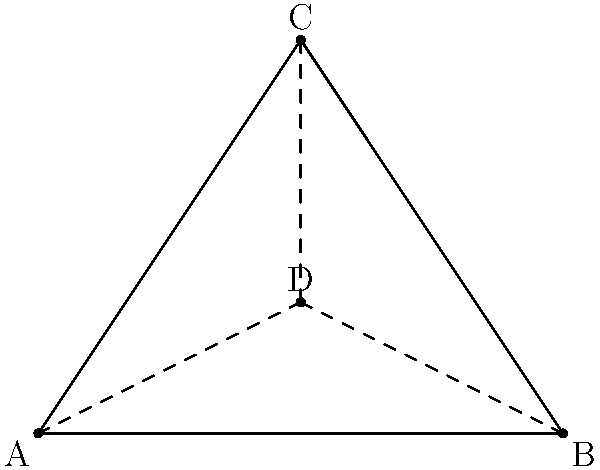In the 1979 South Melbourne FC season, coach Ian Dobson was known for his innovative tactical formations. If he arranged three key players (A, B, and C) in a triangular formation on the field, where should he position the team captain (D) to ensure equal distance from all three players, maximizing communication efficiency? To find the optimal position for the team captain (D) that ensures equal distance from all three players (A, B, and C), we need to follow these steps:

1. Recognize that the point we're looking for is the center of the triangle ABC.

2. In geometry, the center of a triangle that is equidistant from all three vertices is called the centroid.

3. The centroid has a special property: it's located at the intersection of the three medians of the triangle. A median is a line segment that connects a vertex to the midpoint of the opposite side.

4. The centroid divides each median in a 2:1 ratio, meaning it's located 2/3 of the way from any vertex to the midpoint of the opposite side.

5. Mathematically, we can express the coordinates of the centroid (D) as:

   $$D = \frac{A + B + C}{3}$$

   Where A, B, and C are the coordinate pairs of the three vertices.

6. This point D will be equidistant from all three players, allowing the captain to communicate effectively with each of them.

7. In the diagram, point D is shown as the intersection of the three dashed lines (medians) drawn from each vertex to the midpoint of the opposite side.

This formation would allow for optimal communication between the captain and the three key players, potentially improving team coordination during crucial moments of the game.
Answer: At the centroid of the triangle formed by the three players. 